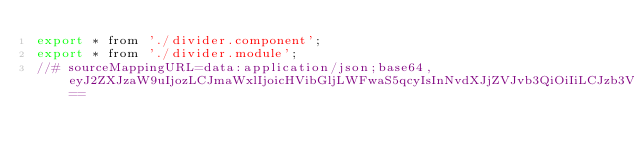Convert code to text. <code><loc_0><loc_0><loc_500><loc_500><_JavaScript_>export * from './divider.component';
export * from './divider.module';
//# sourceMappingURL=data:application/json;base64,eyJ2ZXJzaW9uIjozLCJmaWxlIjoicHVibGljLWFwaS5qcyIsInNvdXJjZVJvb3QiOiIiLCJzb3VyY2VzIjpbIi4uLy4uLy4uLy4uL3BhY2thZ2VzL21vc2FpYy9kaXZpZGVyL3B1YmxpYy1hcGkudHMiXSwibmFtZXMiOltdLCJtYXBwaW5ncyI6IkFBQUEsY0FBYyxxQkFBcUIsQ0FBQztBQUNwQyxjQUFjLGtCQUFrQixDQUFDIiwic291cmNlc0NvbnRlbnQiOlsiZXhwb3J0ICogZnJvbSAnLi9kaXZpZGVyLmNvbXBvbmVudCc7XG5leHBvcnQgKiBmcm9tICcuL2RpdmlkZXIubW9kdWxlJztcbiJdfQ==</code> 